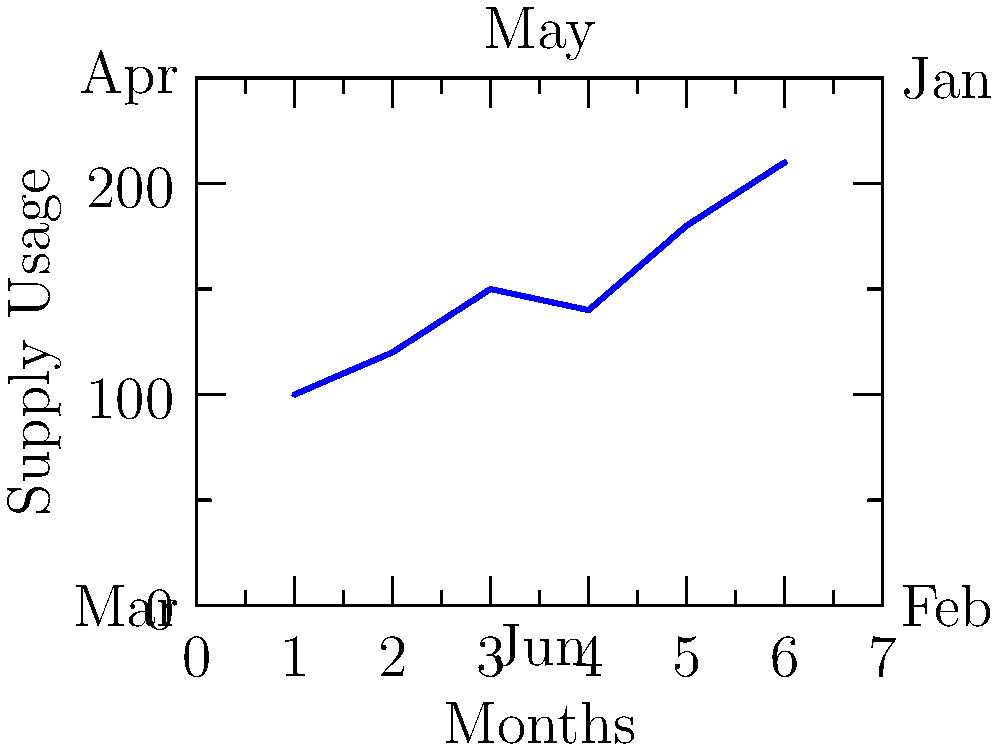Based on the line graph showing hospital supply usage trends over six months, what is the percentage increase in supply usage from January to June? To calculate the percentage increase in supply usage from January to June, we'll follow these steps:

1. Identify the supply usage values:
   - January (start): 100 units
   - June (end): 210 units

2. Calculate the difference in usage:
   $210 - 100 = 110$ units

3. Calculate the percentage increase:
   Percentage increase = $\frac{\text{Increase}}{\text{Original Value}} \times 100\%$
   
   $= \frac{110}{100} \times 100\%$
   
   $= 1.1 \times 100\%$
   
   $= 110\%$

Therefore, the percentage increase in supply usage from January to June is 110%.
Answer: 110% 